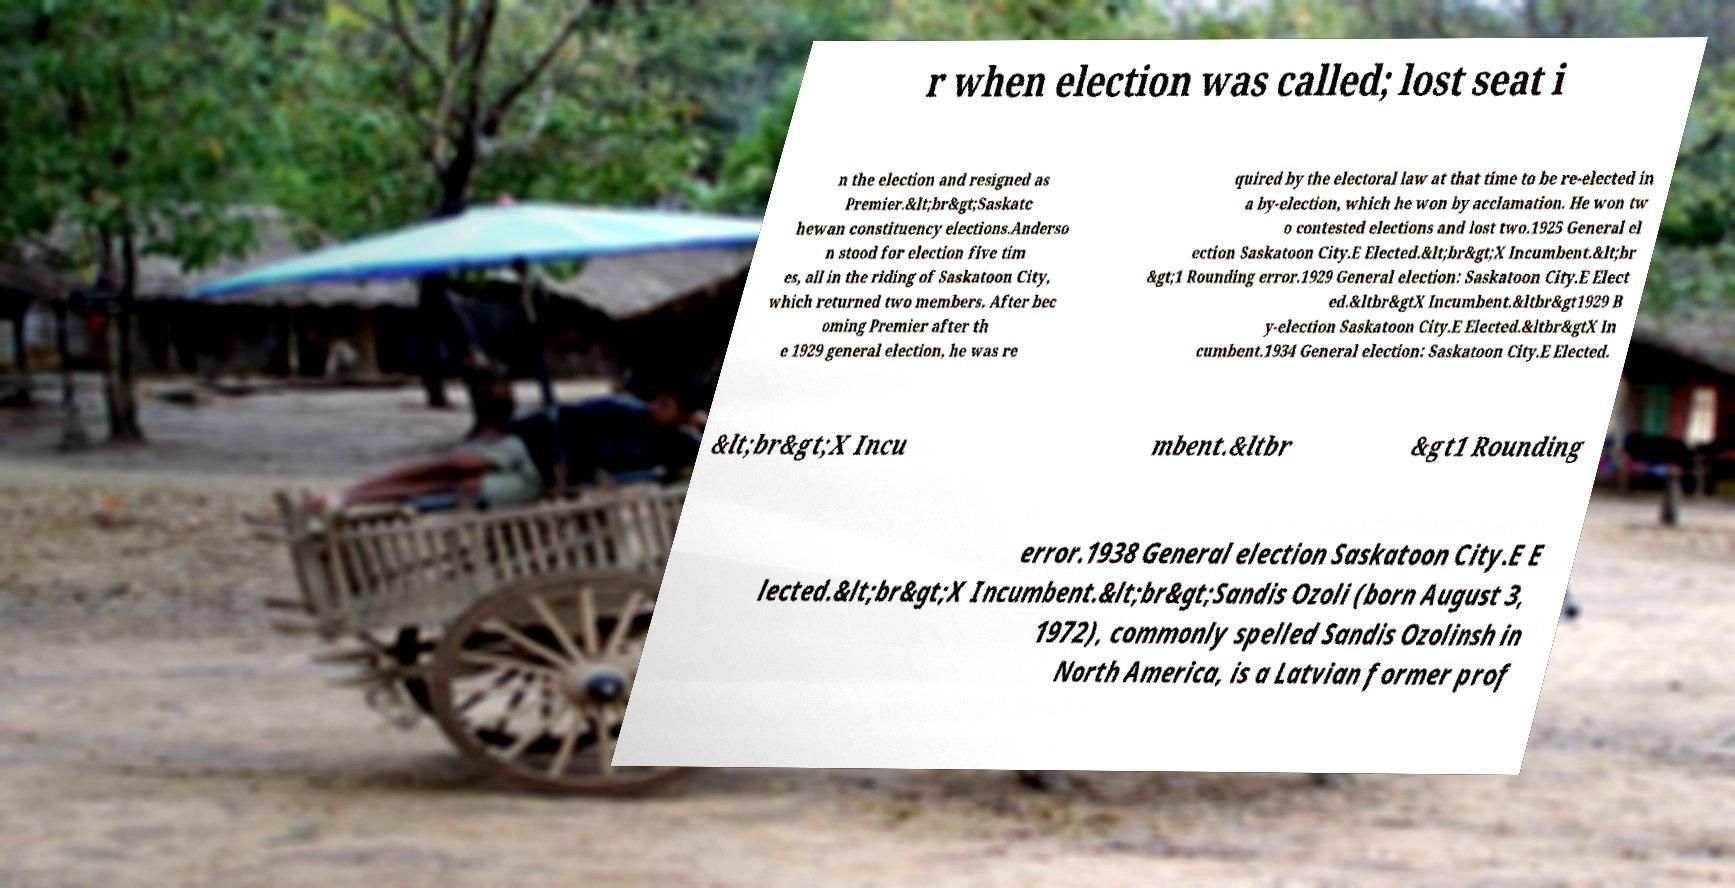What messages or text are displayed in this image? I need them in a readable, typed format. r when election was called; lost seat i n the election and resigned as Premier.&lt;br&gt;Saskatc hewan constituency elections.Anderso n stood for election five tim es, all in the riding of Saskatoon City, which returned two members. After bec oming Premier after th e 1929 general election, he was re quired by the electoral law at that time to be re-elected in a by-election, which he won by acclamation. He won tw o contested elections and lost two.1925 General el ection Saskatoon City.E Elected.&lt;br&gt;X Incumbent.&lt;br &gt;1 Rounding error.1929 General election: Saskatoon City.E Elect ed.&ltbr&gtX Incumbent.&ltbr&gt1929 B y-election Saskatoon City.E Elected.&ltbr&gtX In cumbent.1934 General election: Saskatoon City.E Elected. &lt;br&gt;X Incu mbent.&ltbr &gt1 Rounding error.1938 General election Saskatoon City.E E lected.&lt;br&gt;X Incumbent.&lt;br&gt;Sandis Ozoli (born August 3, 1972), commonly spelled Sandis Ozolinsh in North America, is a Latvian former prof 